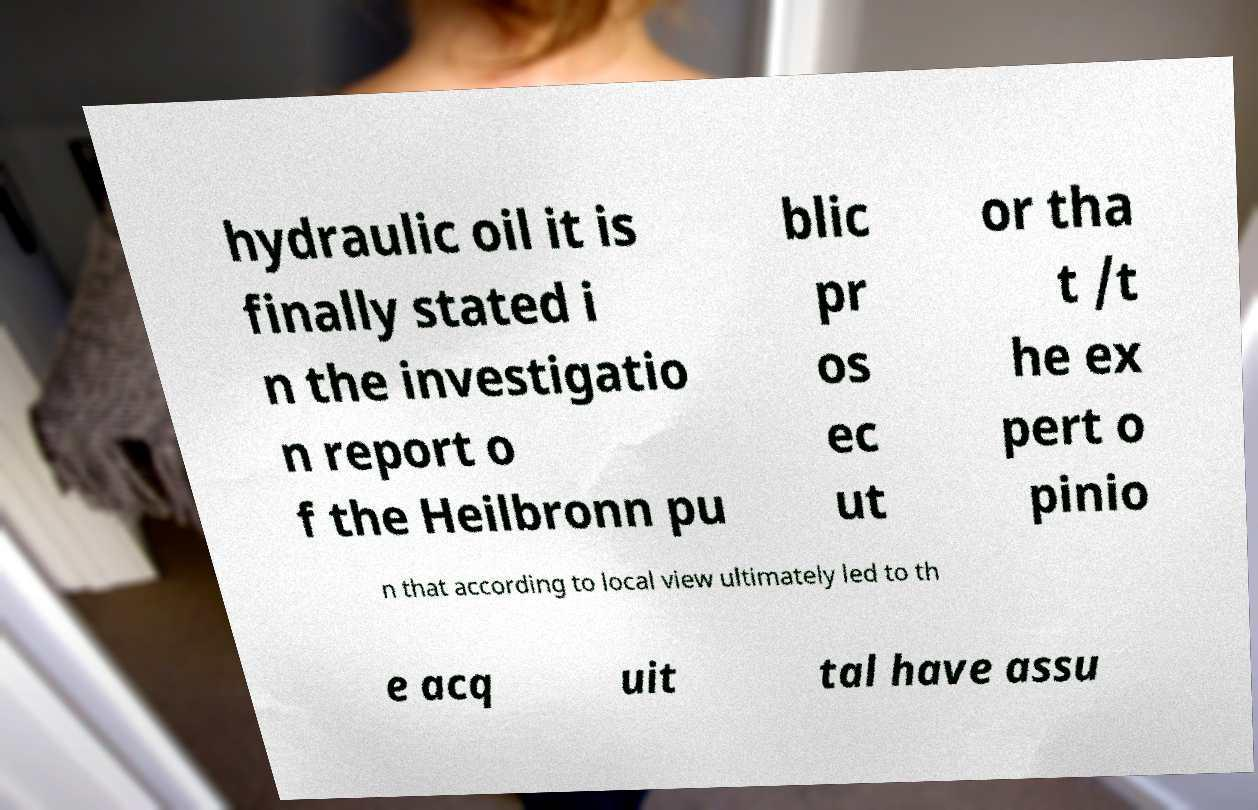There's text embedded in this image that I need extracted. Can you transcribe it verbatim? hydraulic oil it is finally stated i n the investigatio n report o f the Heilbronn pu blic pr os ec ut or tha t /t he ex pert o pinio n that according to local view ultimately led to th e acq uit tal have assu 